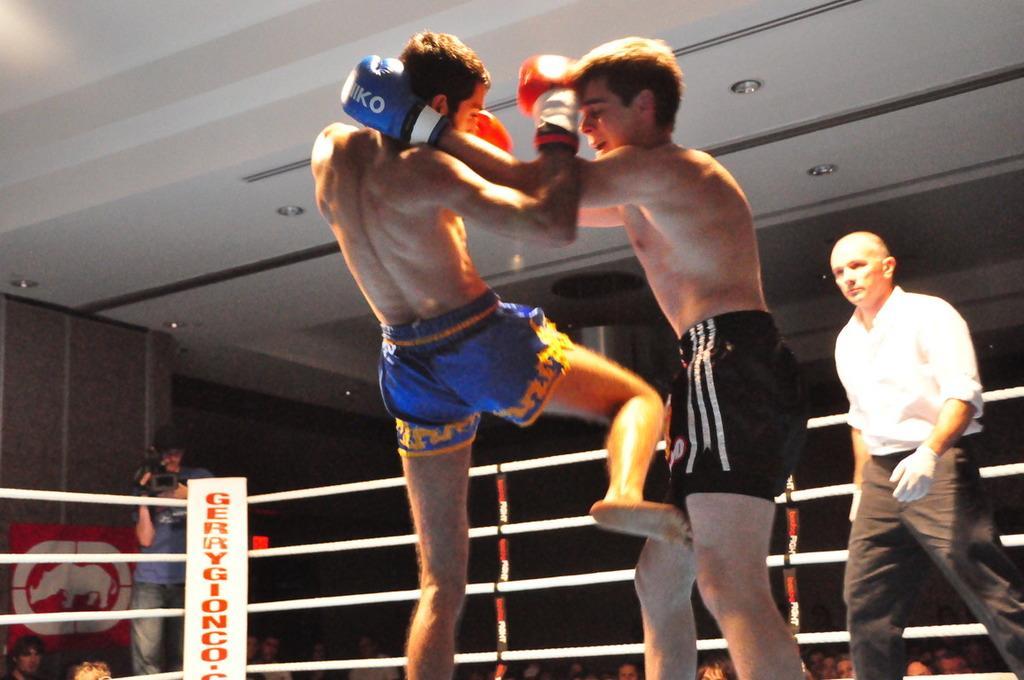Can you describe this image briefly? In this picture we can see three men wore gloves and standing in a boxing ring and in the background we can see a group of people and a man holding a camera with his hands and standing, poster on the wall and some objects. 